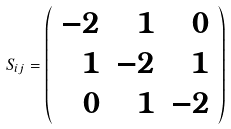Convert formula to latex. <formula><loc_0><loc_0><loc_500><loc_500>S _ { i j } = \left ( \begin{array} { r r r } { - 2 } & { 1 } & { 0 } \\ { 1 } & { - 2 } & { 1 } \\ { 0 } & { 1 } & { - 2 } \end{array} \right )</formula> 